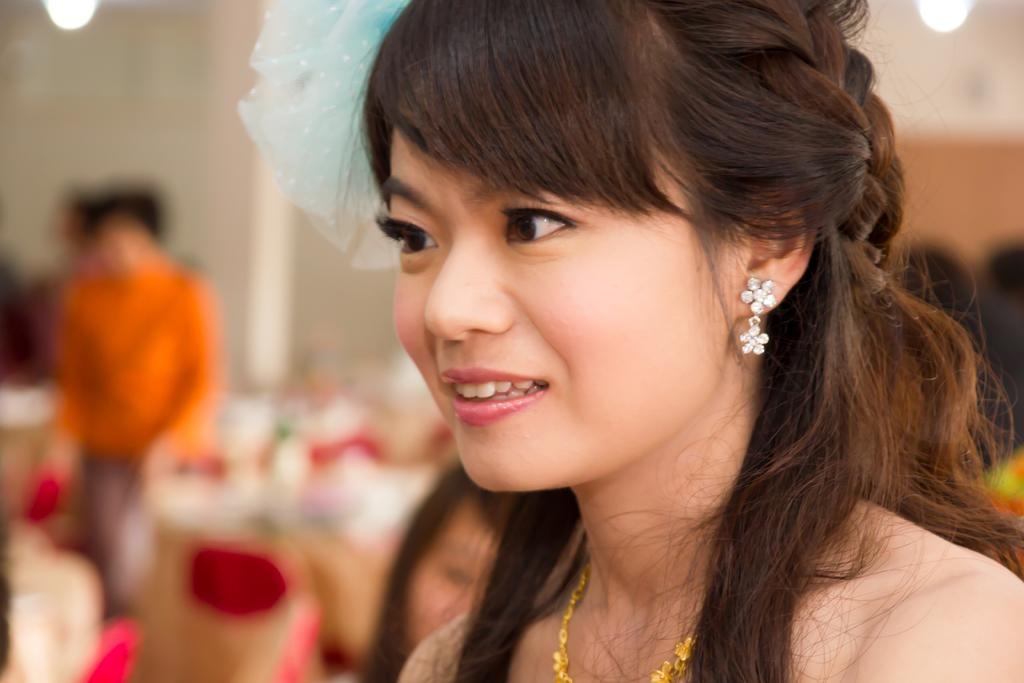Who is present in the image? There is a woman in the image. What is the woman's facial expression? The woman is smiling. Can you describe the background of the image? There are persons visible in the background of the image. What type of drain is visible in the image? There is no drain present in the image. How many baskets can be seen in the image? There are no baskets present in the image. 